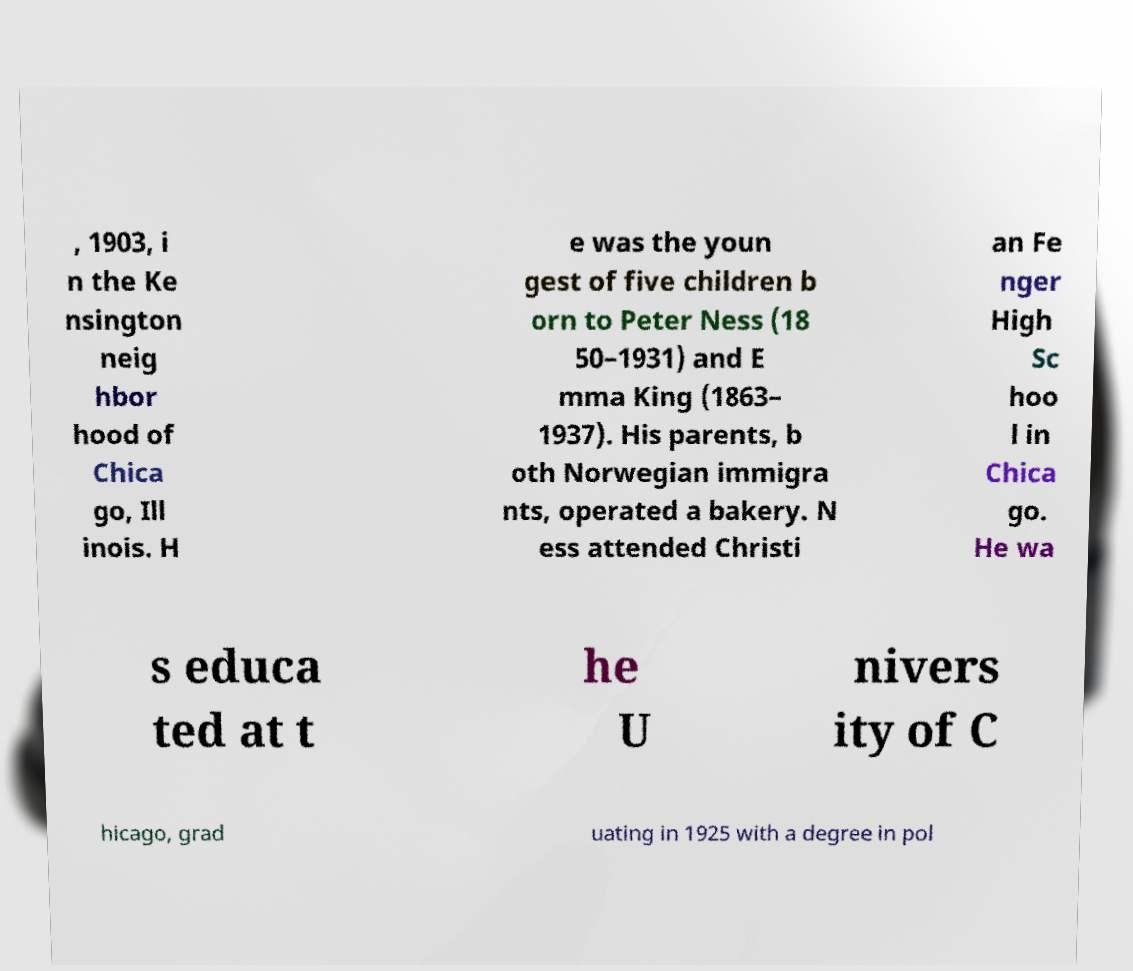I need the written content from this picture converted into text. Can you do that? , 1903, i n the Ke nsington neig hbor hood of Chica go, Ill inois. H e was the youn gest of five children b orn to Peter Ness (18 50–1931) and E mma King (1863– 1937). His parents, b oth Norwegian immigra nts, operated a bakery. N ess attended Christi an Fe nger High Sc hoo l in Chica go. He wa s educa ted at t he U nivers ity of C hicago, grad uating in 1925 with a degree in pol 